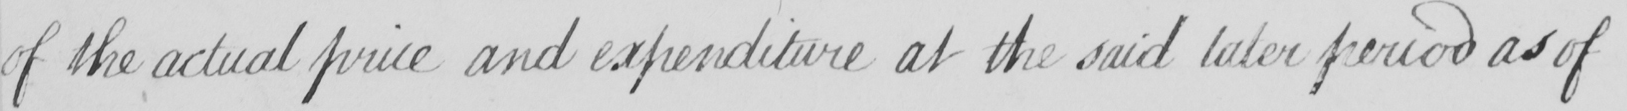What text is written in this handwritten line? of the actual price and expenditure at the said later period as of 